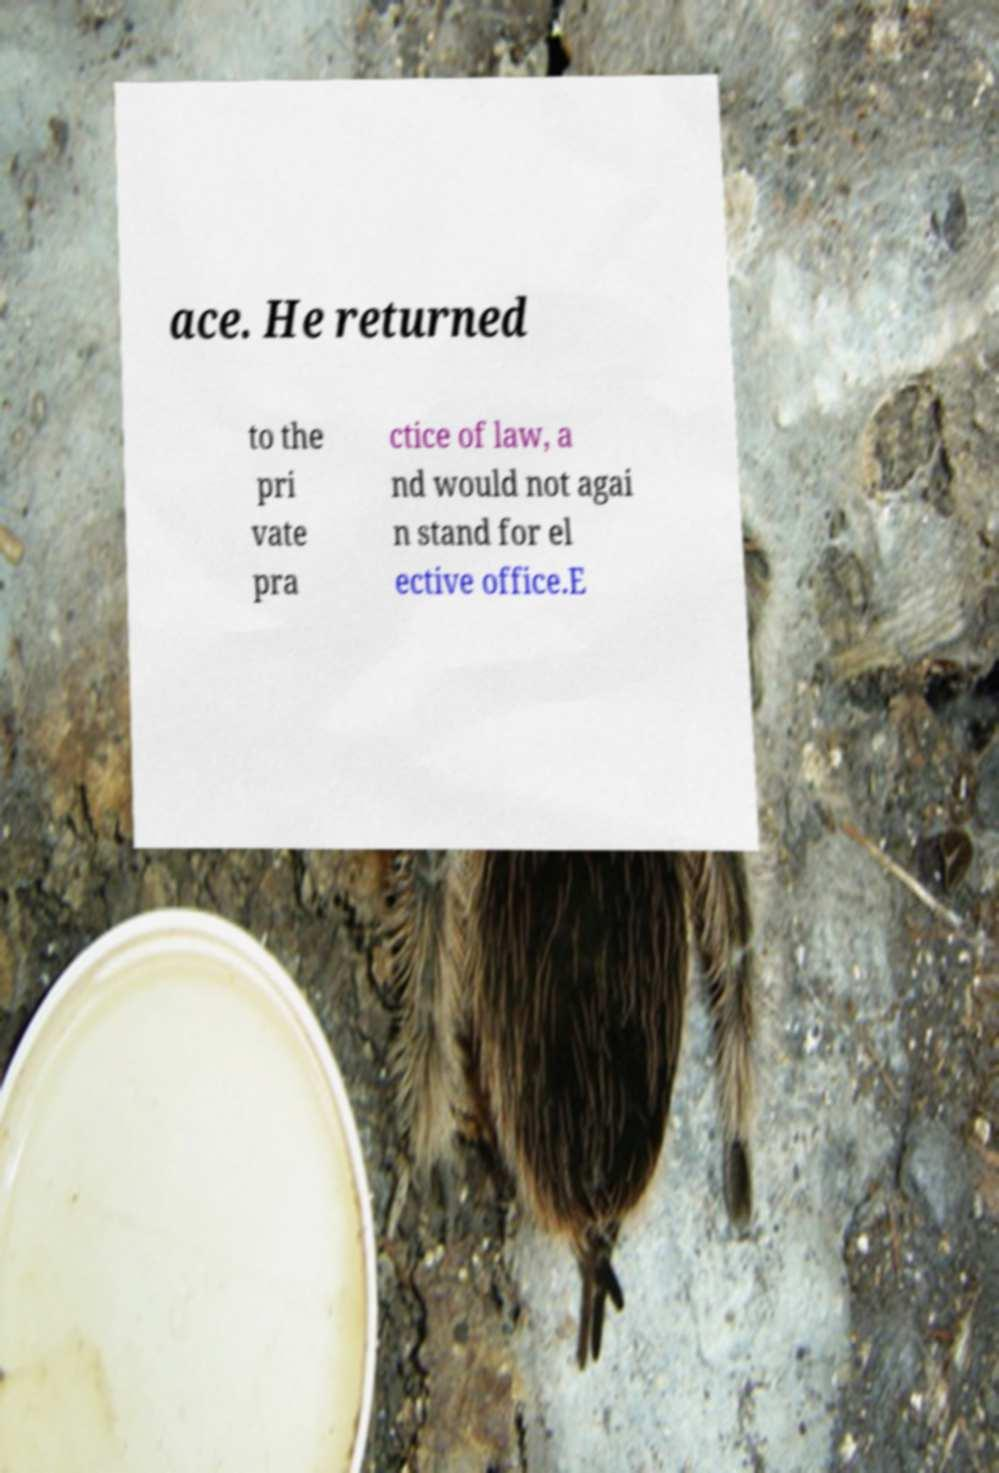Can you read and provide the text displayed in the image?This photo seems to have some interesting text. Can you extract and type it out for me? ace. He returned to the pri vate pra ctice of law, a nd would not agai n stand for el ective office.E 